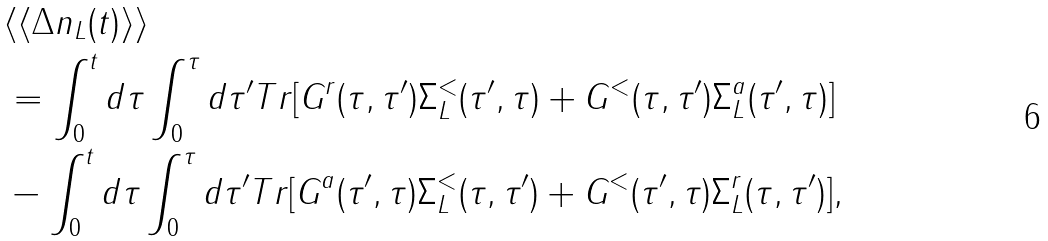<formula> <loc_0><loc_0><loc_500><loc_500>& \langle \langle \Delta n _ { L } ( t ) \rangle \rangle \\ & = \int _ { 0 } ^ { t } d \tau \int _ { 0 } ^ { \tau } d \tau ^ { \prime } T r [ G ^ { r } ( \tau , \tau ^ { \prime } ) \Sigma _ { L } ^ { < } ( \tau ^ { \prime } , \tau ) + G ^ { < } ( \tau , \tau ^ { \prime } ) \Sigma _ { L } ^ { a } ( \tau ^ { \prime } , \tau ) ] \\ & - \int _ { 0 } ^ { t } d \tau \int _ { 0 } ^ { \tau } d \tau ^ { \prime } T r [ G ^ { a } ( \tau ^ { \prime } , \tau ) \Sigma _ { L } ^ { < } ( \tau , \tau ^ { \prime } ) + G ^ { < } ( \tau ^ { \prime } , \tau ) \Sigma _ { L } ^ { r } ( \tau , \tau ^ { \prime } ) ] ,</formula> 